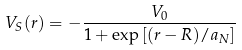<formula> <loc_0><loc_0><loc_500><loc_500>V _ { S } ( r ) = - \frac { V _ { 0 } } { 1 + \exp \left [ ( r - R ) / a _ { N } \right ] }</formula> 